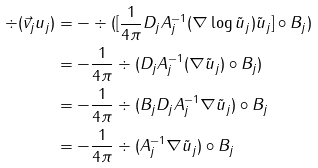Convert formula to latex. <formula><loc_0><loc_0><loc_500><loc_500>\div ( \vec { v } _ { j } u _ { j } ) & = - \div ( [ \frac { 1 } { 4 \pi } D _ { j } A _ { j } ^ { - 1 } ( \nabla \log \tilde { u } _ { j } ) \tilde { u } _ { j } ] \circ B _ { j } ) \\ & = - \frac { 1 } { 4 \pi } \div ( D _ { j } A _ { j } ^ { - 1 } ( \nabla \tilde { u } _ { j } ) \circ B _ { j } ) \\ & = - \frac { 1 } { 4 \pi } \div ( B _ { j } D _ { j } A _ { j } ^ { - 1 } \nabla \tilde { u } _ { j } ) \circ B _ { j } \\ & = - \frac { 1 } { 4 \pi } \div ( A _ { j } ^ { - 1 } \nabla \tilde { u } _ { j } ) \circ B _ { j }</formula> 